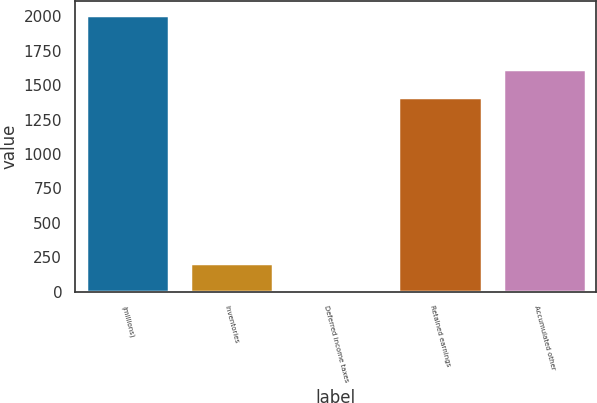Convert chart. <chart><loc_0><loc_0><loc_500><loc_500><bar_chart><fcel>(millions)<fcel>Inventories<fcel>Deferred income taxes<fcel>Retained earnings<fcel>Accumulated other<nl><fcel>2011<fcel>206.5<fcel>6<fcel>1416<fcel>1616.5<nl></chart> 